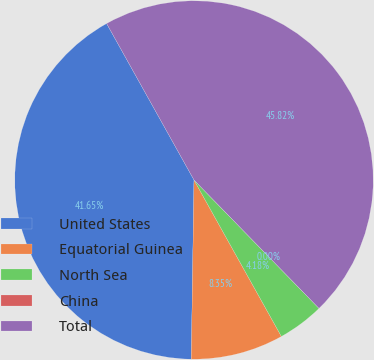Convert chart. <chart><loc_0><loc_0><loc_500><loc_500><pie_chart><fcel>United States<fcel>Equatorial Guinea<fcel>North Sea<fcel>China<fcel>Total<nl><fcel>41.65%<fcel>8.35%<fcel>4.18%<fcel>0.0%<fcel>45.82%<nl></chart> 